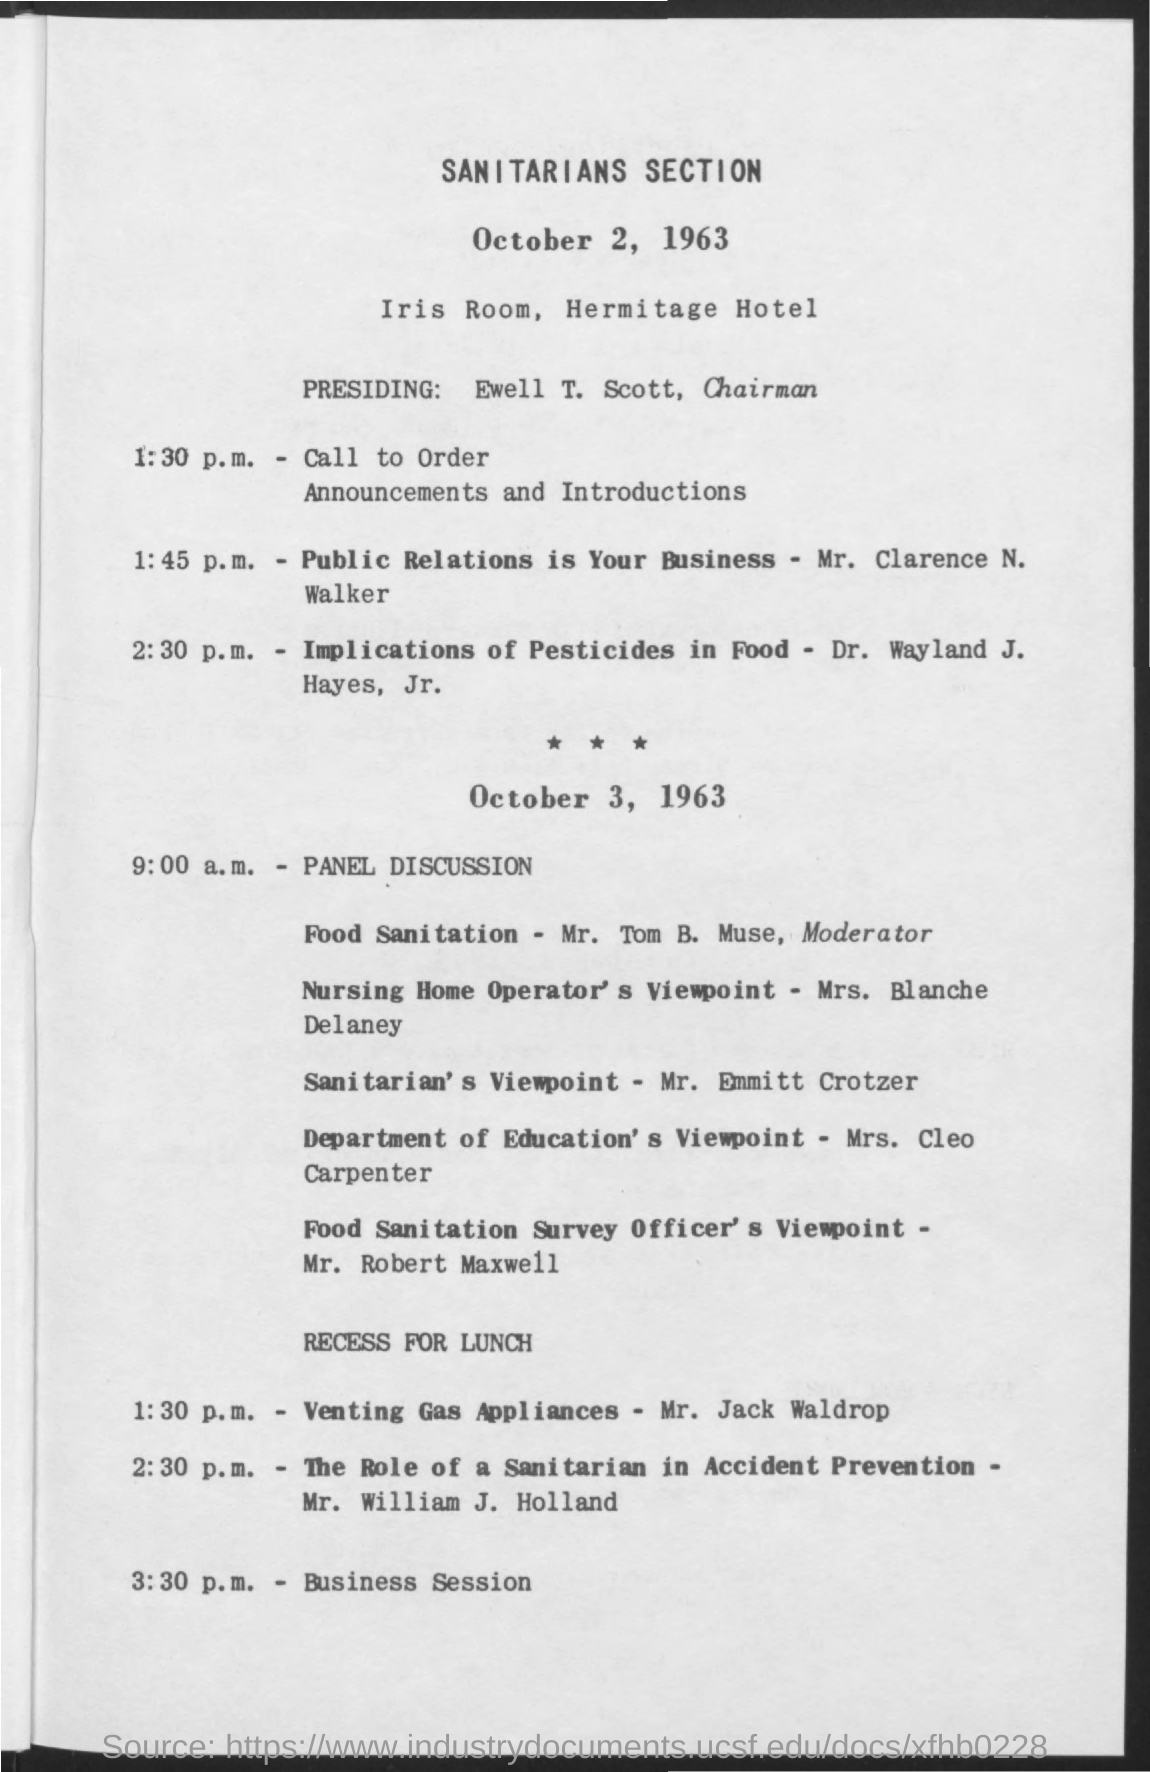What is the name of the chairman mentioned ?
Your answer should be very brief. Ewell t. scott. What is the name of the hotel mentioned ?
Keep it short and to the point. Hermitage Hotel. What is the time mentioned for business session
Give a very brief answer. 3:30 p.m. What is the time mentioned for panel discussion ?
Ensure brevity in your answer.  9:00 a.m. What is the title mentioned in the bold letters
Your answer should be compact. SANITARIANS SECTION. 